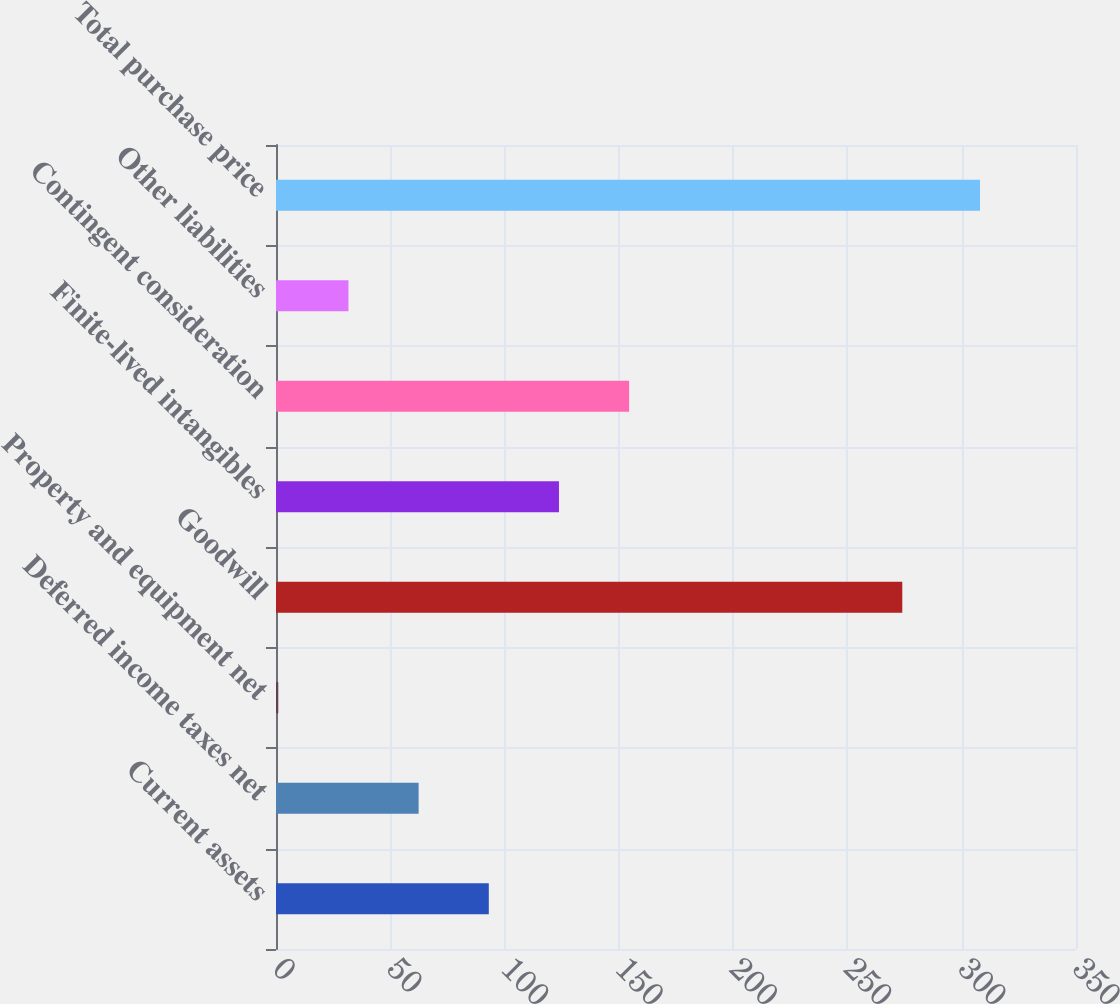<chart> <loc_0><loc_0><loc_500><loc_500><bar_chart><fcel>Current assets<fcel>Deferred income taxes net<fcel>Property and equipment net<fcel>Goodwill<fcel>Finite-lived intangibles<fcel>Contingent consideration<fcel>Other liabilities<fcel>Total purchase price<nl><fcel>93.1<fcel>62.4<fcel>1<fcel>274<fcel>123.8<fcel>154.5<fcel>31.7<fcel>308<nl></chart> 